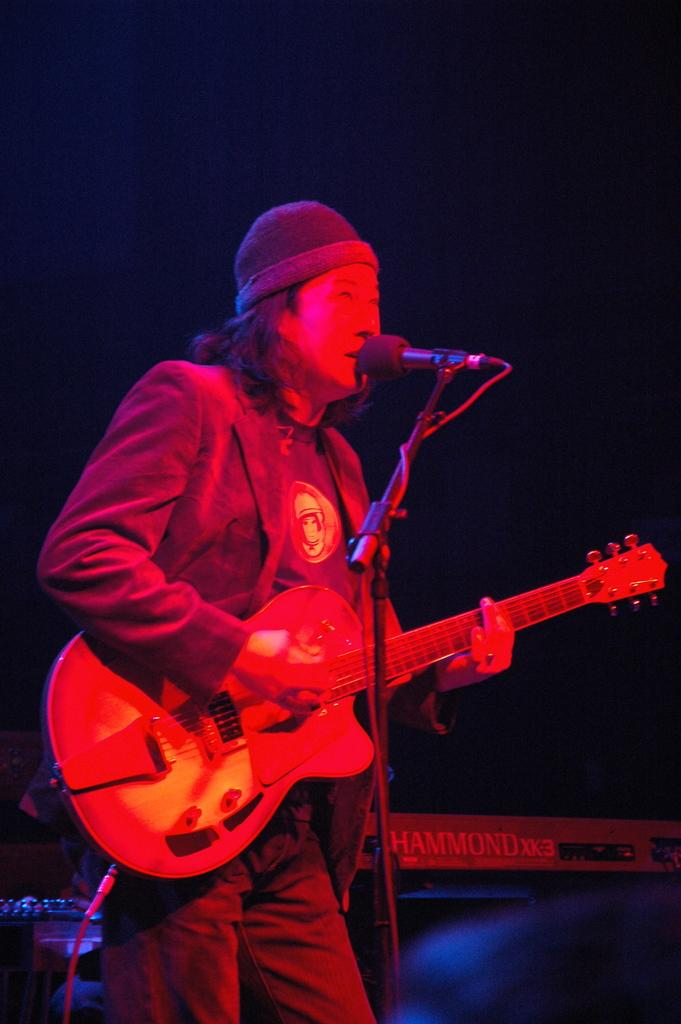What is the main subject of the image? There is a man in the image. What is the man doing in the image? The man is standing in the image. What object is the man holding in his hand? The man is holding a guitar in his hand. What is in front of the man? There is a microphone in front of the man. What type of clothing is the man wearing on his head? The man is wearing a cap. What type of lumber is the man using to play the guitar in the image? There is no lumber present in the image; the man is playing a guitar, which is a musical instrument made of wood and other materials. How many socks can be seen on the man's feet in the image? There is no information about the man's feet or socks in the image. 